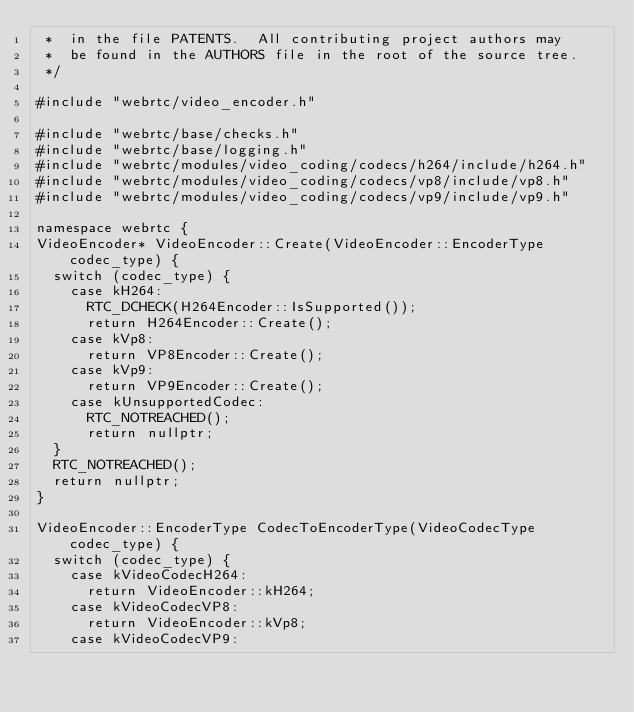Convert code to text. <code><loc_0><loc_0><loc_500><loc_500><_C++_> *  in the file PATENTS.  All contributing project authors may
 *  be found in the AUTHORS file in the root of the source tree.
 */

#include "webrtc/video_encoder.h"

#include "webrtc/base/checks.h"
#include "webrtc/base/logging.h"
#include "webrtc/modules/video_coding/codecs/h264/include/h264.h"
#include "webrtc/modules/video_coding/codecs/vp8/include/vp8.h"
#include "webrtc/modules/video_coding/codecs/vp9/include/vp9.h"

namespace webrtc {
VideoEncoder* VideoEncoder::Create(VideoEncoder::EncoderType codec_type) {
  switch (codec_type) {
    case kH264:
      RTC_DCHECK(H264Encoder::IsSupported());
      return H264Encoder::Create();
    case kVp8:
      return VP8Encoder::Create();
    case kVp9:
      return VP9Encoder::Create();
    case kUnsupportedCodec:
      RTC_NOTREACHED();
      return nullptr;
  }
  RTC_NOTREACHED();
  return nullptr;
}

VideoEncoder::EncoderType CodecToEncoderType(VideoCodecType codec_type) {
  switch (codec_type) {
    case kVideoCodecH264:
      return VideoEncoder::kH264;
    case kVideoCodecVP8:
      return VideoEncoder::kVp8;
    case kVideoCodecVP9:</code> 